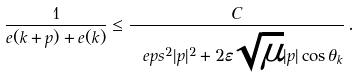<formula> <loc_0><loc_0><loc_500><loc_500>\frac { 1 } { e ( k + p ) + e ( k ) } \leq \frac { C } { \ e p s ^ { 2 } | p | ^ { 2 } + 2 \varepsilon \sqrt { \mu } | p | \cos \theta _ { k } } \, .</formula> 